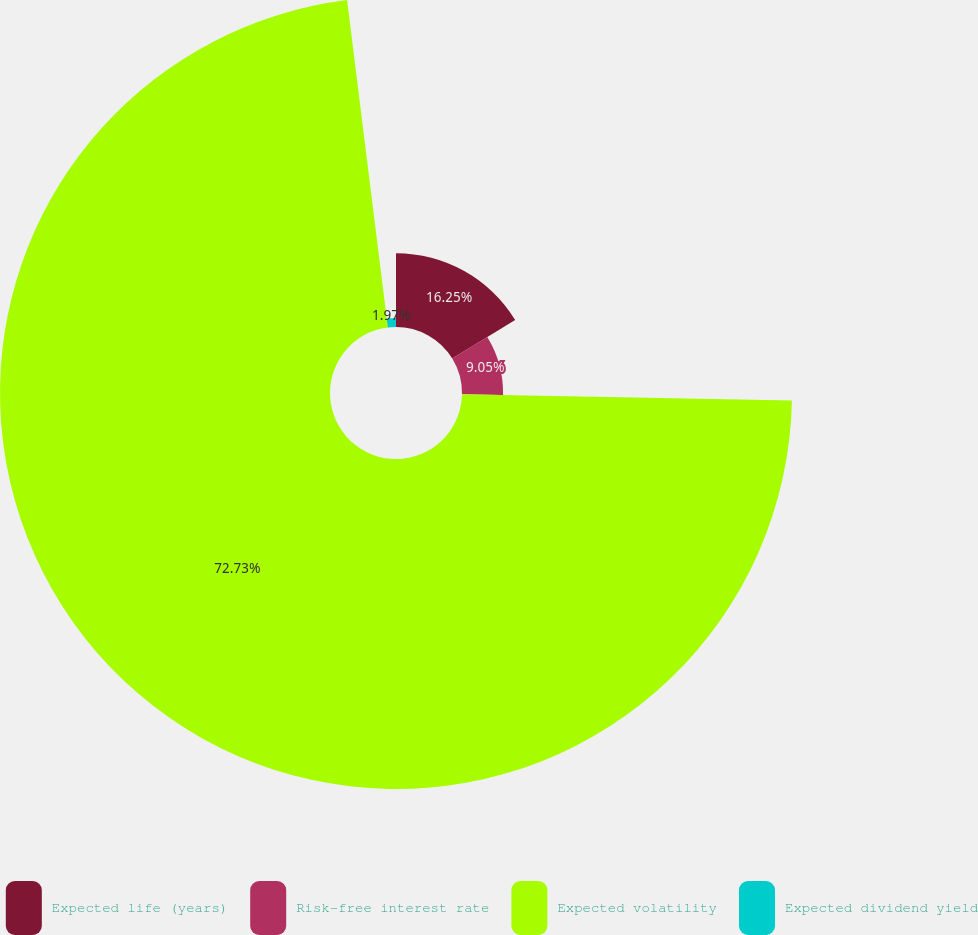<chart> <loc_0><loc_0><loc_500><loc_500><pie_chart><fcel>Expected life (years)<fcel>Risk-free interest rate<fcel>Expected volatility<fcel>Expected dividend yield<nl><fcel>16.25%<fcel>9.05%<fcel>72.73%<fcel>1.97%<nl></chart> 